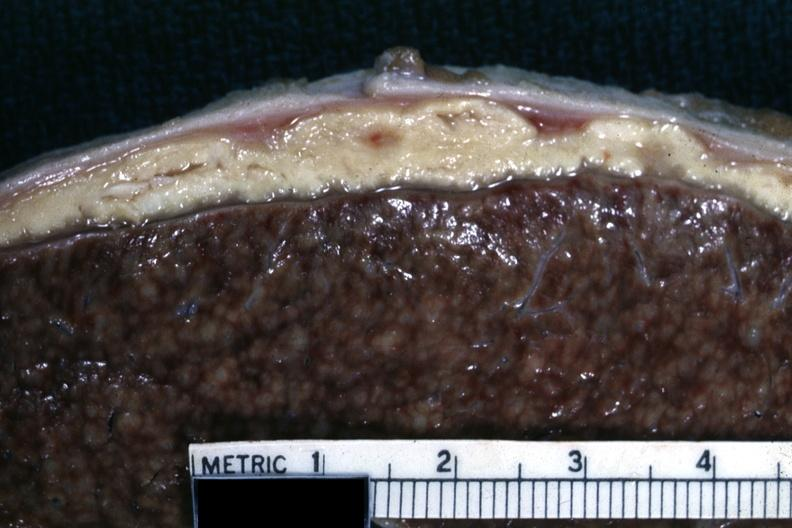how does this image show close-up of liver?
Answer the question using a single word or phrase. With typical gray caseous looking material that can be seen with tuberculous peritonitis 